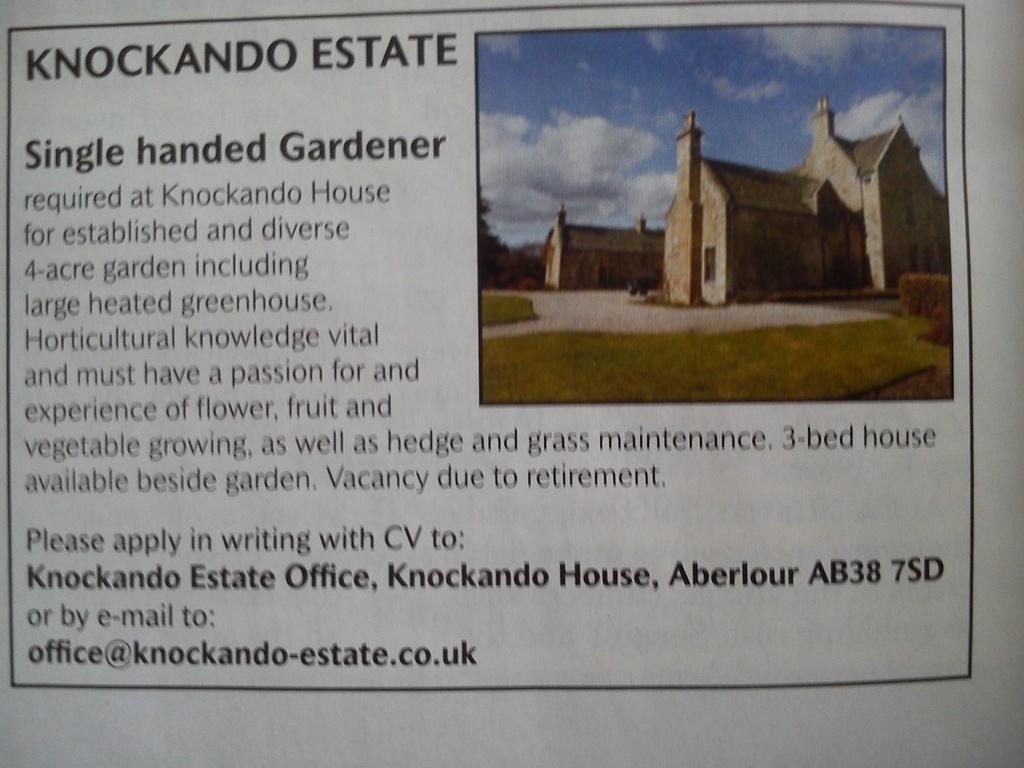What colors are used for the buildings in the image? The buildings in the image are in brown and cream colors. What type of vegetation is present in the image? There are trees in green color in the image. What colors can be seen in the sky in the image? The sky is in blue and white color in the image. Is there any text or writing in the image? Yes, there is something written on the image. Can you compare the length of the bridge in the image to the height of the trees? There is no bridge present in the image, so it is not possible to make a comparison. 